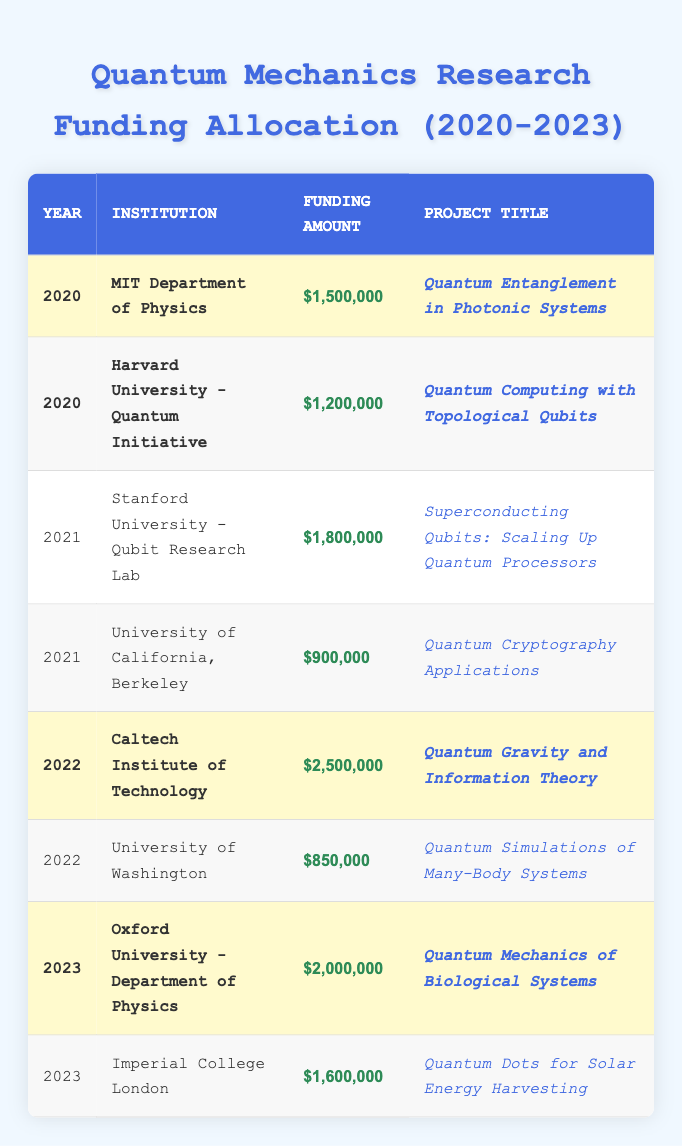What is the highest funding amount for a single project in 2022? The table shows that in 2022, the highest funding amount is $2,500,000 awarded to the Caltech Institute of Technology for the project titled "Quantum Gravity and Information Theory."
Answer: $2,500,000 How many projects received funding in 2020? The table lists two projects in 2020: one from MIT Department of Physics and one from Harvard University - Quantum Initiative, making the total count two.
Answer: 2 What is the average funding amount for the highlighted projects? The highlighted funding amounts are $1,500,000, $1,200,000, $2,500,000, and $2,000,000. Summing these gives $1,500,000 + $1,200,000 + $2,500,000 + $2,000,000 = $7,200,000. There are 4 highlighted projects, so the average is $7,200,000 / 4 = $1,800,000.
Answer: $1,800,000 Did any project in 2021 receive more funding than the highest funded project in 2020? The highest funded project in 2020 received $1,500,000. In 2021, the project at Stanford University received $1,800,000, which is more than this amount, confirming the statement as true.
Answer: Yes What is the total funding amount awarded across all years listed? First, we will sum the funding amounts: $1,500,000 (2020, MIT) + $1,200,000 (2020, Harvard) + $1,800,000 (2021, Stanford) + $900,000 (2021, Berkeley) + $2,500,000 (2022, Caltech) + $850,000 (2022, Washington) + $2,000,000 (2023, Oxford) + $1,600,000 (2023, Imperial) = $12,350,000.
Answer: $12,350,000 Which institution received the second highest funding amount, and what was that amount? The second highest funding amount was $2,000,000 awarded to Oxford University for its 2023 project on "Quantum Mechanics of Biological Systems."
Answer: Oxford University - $2,000,000 In which year did the University of California, Berkeley receive funding, and how much was it? The University of California, Berkeley received funding in 2021, and the amount was $900,000 as indicated in the relevant row.
Answer: 2021 - $900,000 How does the total funding for 2023 compare to the total funding for 2020? Total funding for 2023 is $2,000,000 (Oxford) + $1,600,000 (Imperial) = $3,600,000. Total funding for 2020 is $1,500,000 (MIT) + $1,200,000 (Harvard) = $2,700,000. Since $3,600,000 is greater than $2,700,000, thus 2023 received more funding.
Answer: 2023 had more funding Which project title received the least amount of funding in 2021? The project titled "Quantum Cryptography Applications" at the University of California, Berkeley received the least funding amount of $900,000 in 2021, as highlighted in that entry of the table.
Answer: Quantum Cryptography Applications - $900,000 How much more funding did Caltech Institute of Technology receive compared to MIT Department of Physics in 2022? Caltech received $2,500,000 while MIT received $1,500,000 in 2020. To find the difference: $2,500,000 - $1,500,000 = $1,000,000. Thus, Caltech received $1,000,000 more than MIT received.
Answer: $1,000,000 more Is the funding for quantum gravity projects growing over the years? The only quantum gravity project listed is from 2022 with $2,500,000, and as there are no quantum gravity projects listed in other years, we cannot establish a growth trend based on available data. Therefore, the answer is no.
Answer: No 